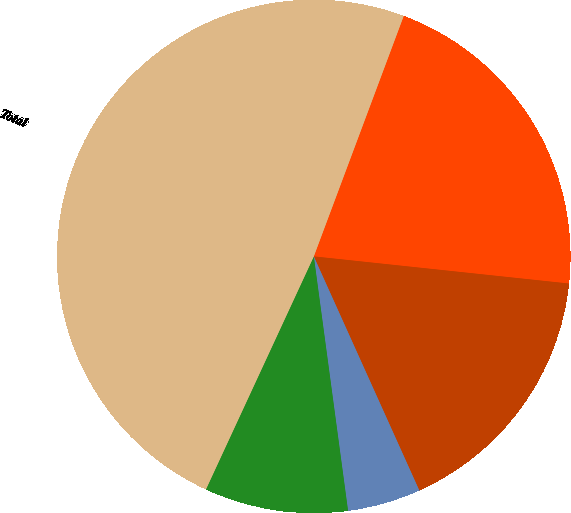Convert chart. <chart><loc_0><loc_0><loc_500><loc_500><pie_chart><fcel>North America<fcel>EMEA^(1)<fcel>Latin America<fcel>APAC^(2)<fcel>Total<nl><fcel>20.99%<fcel>16.57%<fcel>4.61%<fcel>9.03%<fcel>48.79%<nl></chart> 